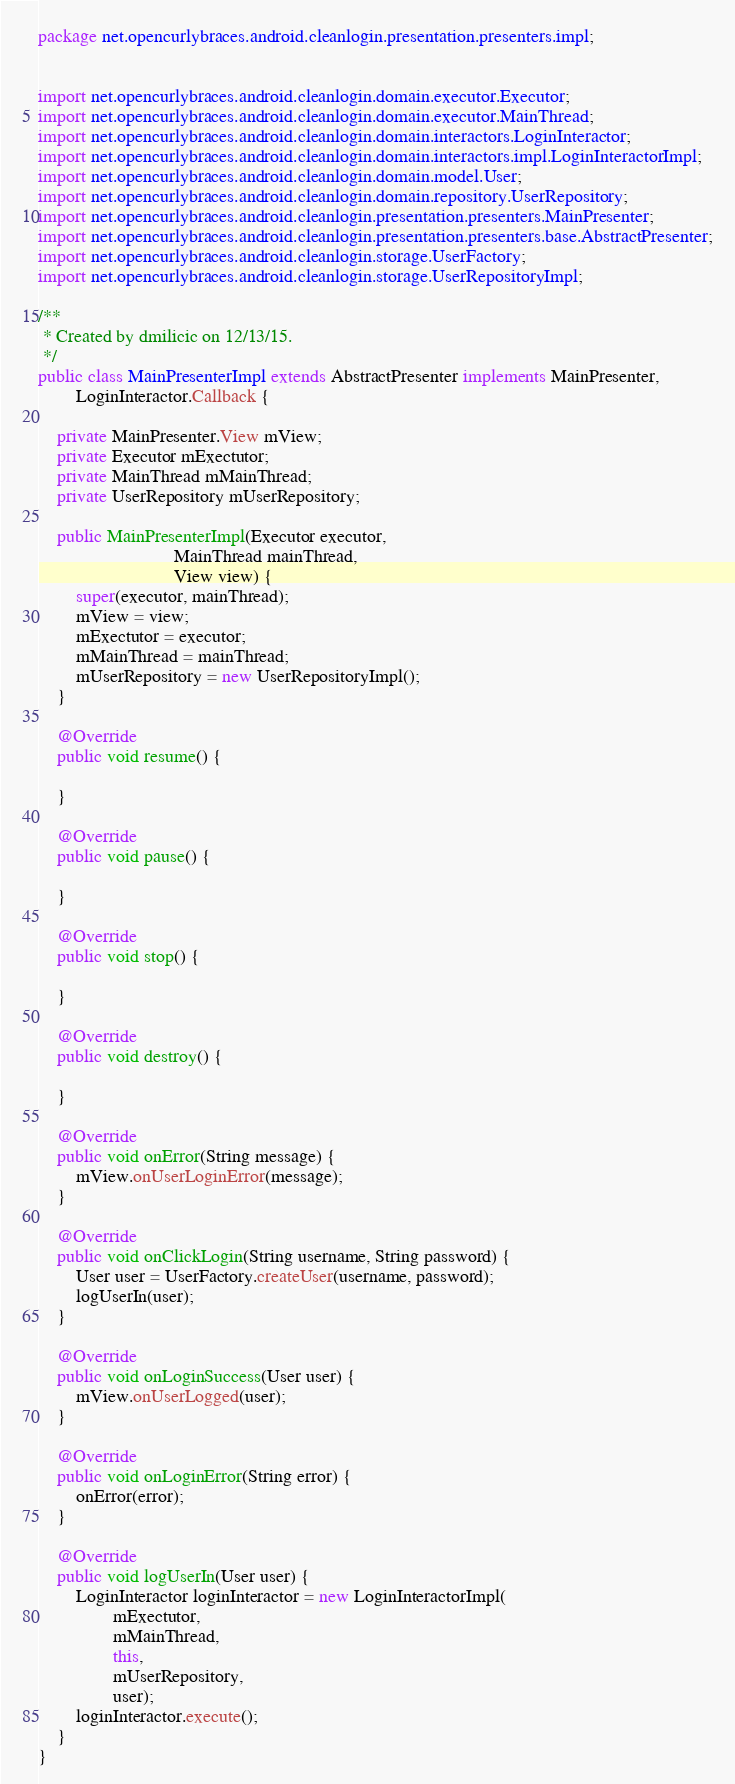<code> <loc_0><loc_0><loc_500><loc_500><_Java_>package net.opencurlybraces.android.cleanlogin.presentation.presenters.impl;


import net.opencurlybraces.android.cleanlogin.domain.executor.Executor;
import net.opencurlybraces.android.cleanlogin.domain.executor.MainThread;
import net.opencurlybraces.android.cleanlogin.domain.interactors.LoginInteractor;
import net.opencurlybraces.android.cleanlogin.domain.interactors.impl.LoginInteractorImpl;
import net.opencurlybraces.android.cleanlogin.domain.model.User;
import net.opencurlybraces.android.cleanlogin.domain.repository.UserRepository;
import net.opencurlybraces.android.cleanlogin.presentation.presenters.MainPresenter;
import net.opencurlybraces.android.cleanlogin.presentation.presenters.base.AbstractPresenter;
import net.opencurlybraces.android.cleanlogin.storage.UserFactory;
import net.opencurlybraces.android.cleanlogin.storage.UserRepositoryImpl;

/**
 * Created by dmilicic on 12/13/15.
 */
public class MainPresenterImpl extends AbstractPresenter implements MainPresenter,
        LoginInteractor.Callback {

    private MainPresenter.View mView;
    private Executor mExectutor;
    private MainThread mMainThread;
    private UserRepository mUserRepository;

    public MainPresenterImpl(Executor executor,
                             MainThread mainThread,
                             View view) {
        super(executor, mainThread);
        mView = view;
        mExectutor = executor;
        mMainThread = mainThread;
        mUserRepository = new UserRepositoryImpl();
    }

    @Override
    public void resume() {

    }

    @Override
    public void pause() {

    }

    @Override
    public void stop() {

    }

    @Override
    public void destroy() {

    }

    @Override
    public void onError(String message) {
        mView.onUserLoginError(message);
    }

    @Override
    public void onClickLogin(String username, String password) {
        User user = UserFactory.createUser(username, password);
        logUserIn(user);
    }

    @Override
    public void onLoginSuccess(User user) {
        mView.onUserLogged(user);
    }

    @Override
    public void onLoginError(String error) {
        onError(error);
    }

    @Override
    public void logUserIn(User user) {
        LoginInteractor loginInteractor = new LoginInteractorImpl(
                mExectutor,
                mMainThread,
                this,
                mUserRepository,
                user);
        loginInteractor.execute();
    }
}
</code> 